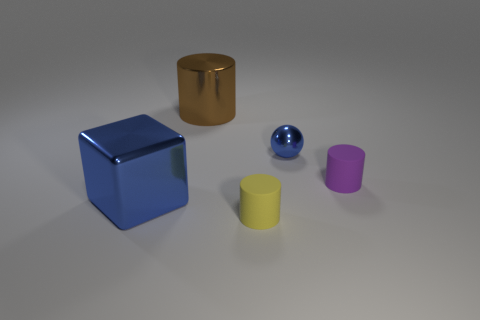Add 1 blue balls. How many objects exist? 6 Subtract all balls. How many objects are left? 4 Subtract all blue shiny objects. Subtract all matte cylinders. How many objects are left? 1 Add 5 tiny yellow objects. How many tiny yellow objects are left? 6 Add 1 tiny metal things. How many tiny metal things exist? 2 Subtract 1 brown cylinders. How many objects are left? 4 